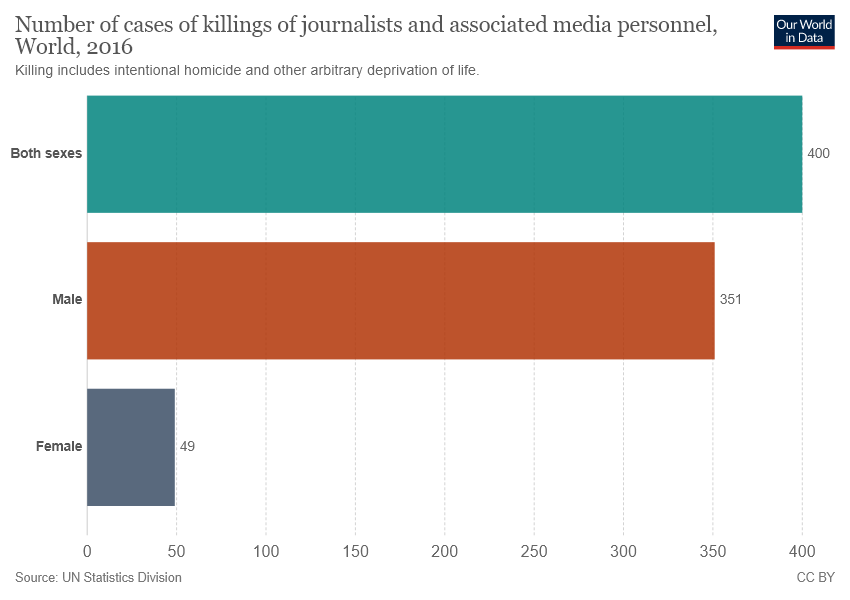Specify some key components in this picture. In 2016, a ratio of 7.16 male and female journalists and associated media personnel were reportedly killed worldwide. In 2016, it was reported that approximately 400 cases of killings of journalists and associated media personnel were committed worldwide. 